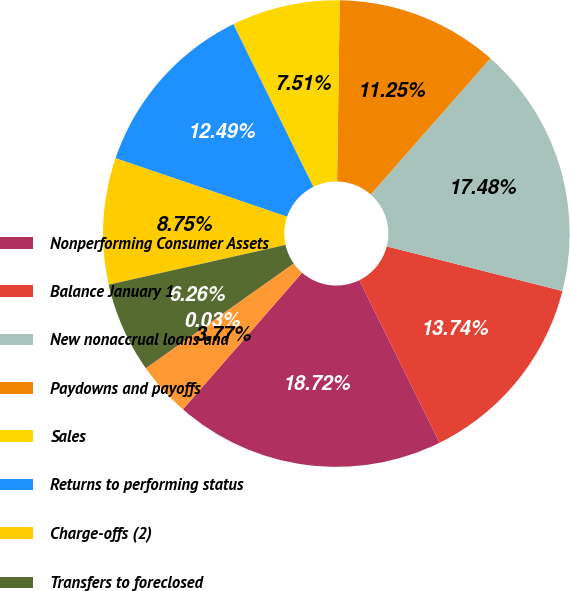Convert chart to OTSL. <chart><loc_0><loc_0><loc_500><loc_500><pie_chart><fcel>Nonperforming Consumer Assets<fcel>Balance January 1<fcel>New nonaccrual loans and<fcel>Paydowns and payoffs<fcel>Sales<fcel>Returns to performing status<fcel>Charge-offs (2)<fcel>Transfers to foreclosed<fcel>Transfers to loans<fcel>Total net additions to<nl><fcel>18.72%<fcel>13.74%<fcel>17.48%<fcel>11.25%<fcel>7.51%<fcel>12.49%<fcel>8.75%<fcel>6.26%<fcel>0.03%<fcel>3.77%<nl></chart> 